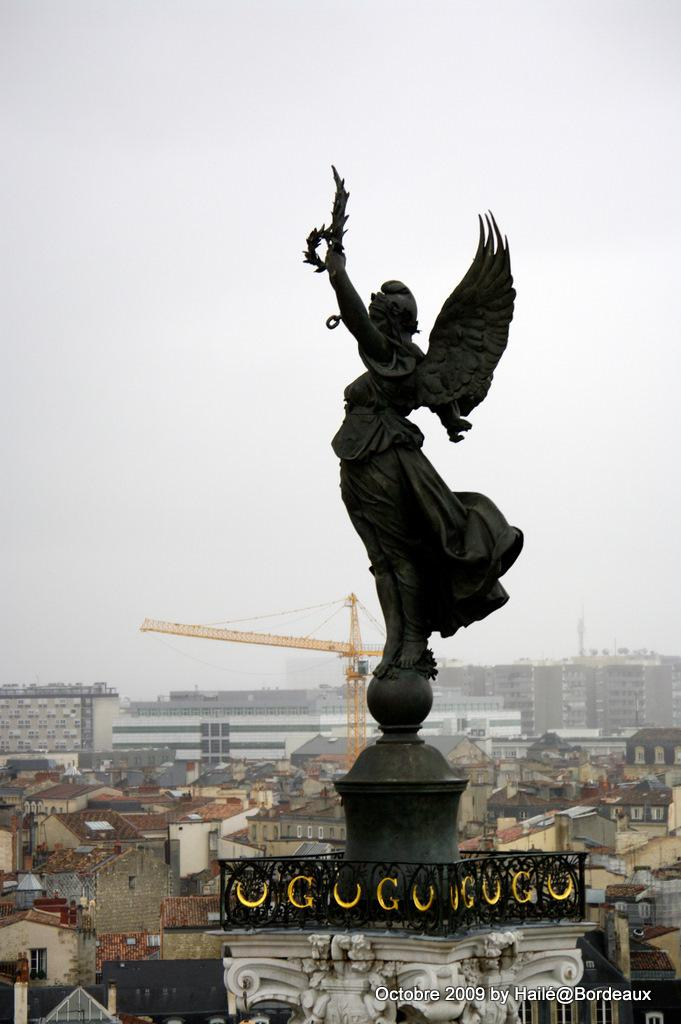What is the main subject in the center of the image? There is a statue in the center of the image. What can be seen in the background of the image? The sky, clouds, buildings, a pole-type structure, fences, and sculptures are visible in the background of the image. Can you see a monkey bursting through a window in the image? There is no monkey or window present in the image. 